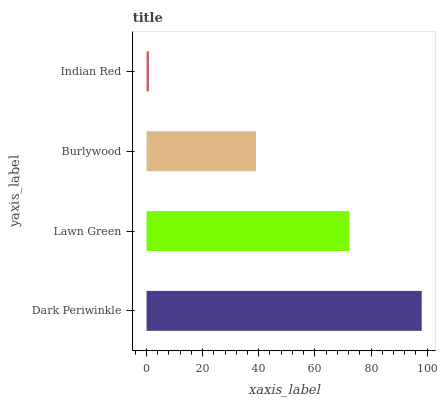Is Indian Red the minimum?
Answer yes or no. Yes. Is Dark Periwinkle the maximum?
Answer yes or no. Yes. Is Lawn Green the minimum?
Answer yes or no. No. Is Lawn Green the maximum?
Answer yes or no. No. Is Dark Periwinkle greater than Lawn Green?
Answer yes or no. Yes. Is Lawn Green less than Dark Periwinkle?
Answer yes or no. Yes. Is Lawn Green greater than Dark Periwinkle?
Answer yes or no. No. Is Dark Periwinkle less than Lawn Green?
Answer yes or no. No. Is Lawn Green the high median?
Answer yes or no. Yes. Is Burlywood the low median?
Answer yes or no. Yes. Is Indian Red the high median?
Answer yes or no. No. Is Dark Periwinkle the low median?
Answer yes or no. No. 